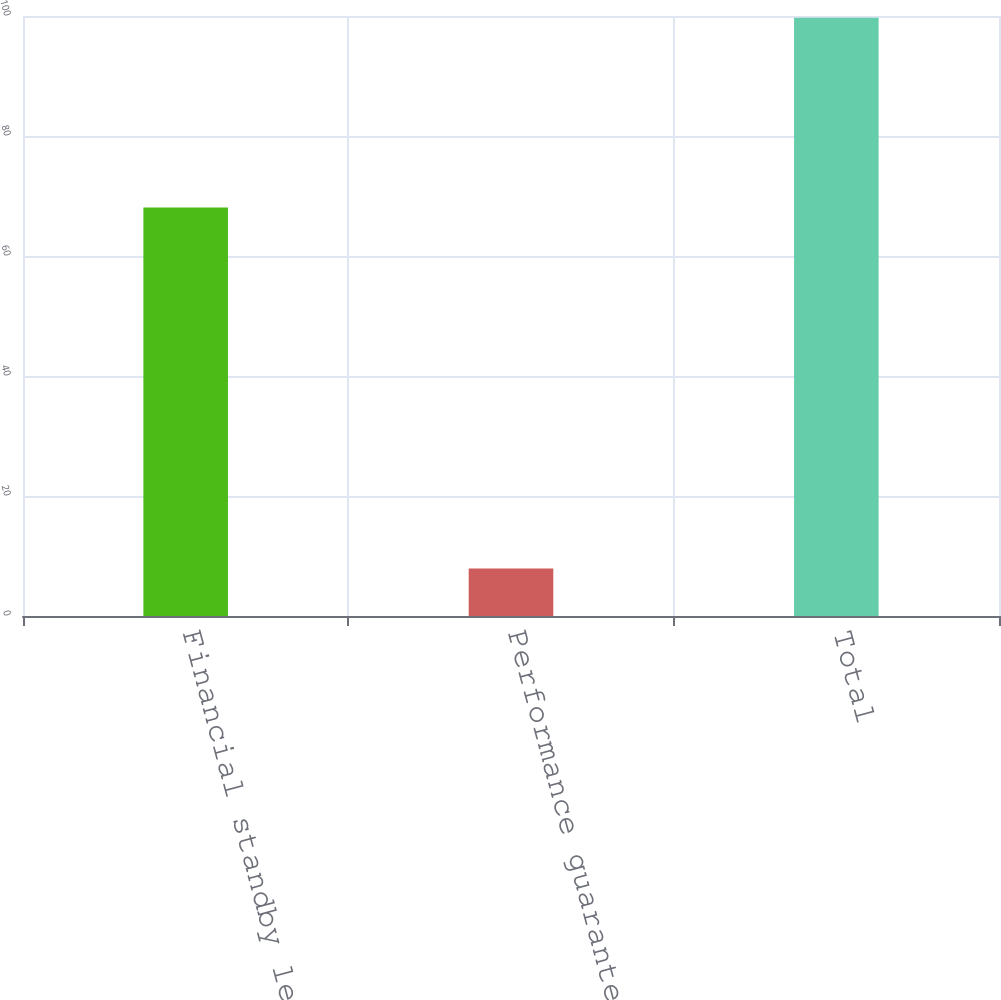<chart> <loc_0><loc_0><loc_500><loc_500><bar_chart><fcel>Financial standby letters of<fcel>Performance guarantees<fcel>Total<nl><fcel>68.1<fcel>7.9<fcel>99.7<nl></chart> 